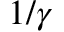<formula> <loc_0><loc_0><loc_500><loc_500>1 / \gamma</formula> 